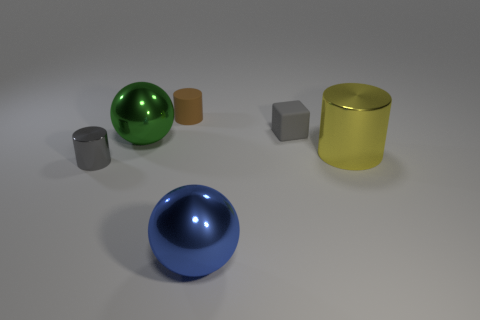There is a metal object in front of the tiny cylinder in front of the big yellow shiny cylinder; what shape is it?
Your response must be concise. Sphere. There is a gray object in front of the small gray thing that is to the right of the tiny cylinder that is on the right side of the tiny gray shiny cylinder; what size is it?
Ensure brevity in your answer.  Small. Do the brown cylinder and the yellow shiny thing have the same size?
Offer a terse response. No. How many things are either green spheres or tiny yellow matte blocks?
Offer a terse response. 1. How big is the gray thing behind the metal object behind the yellow metal thing?
Keep it short and to the point. Small. The brown rubber thing has what size?
Give a very brief answer. Small. There is a tiny object that is in front of the brown matte cylinder and on the left side of the tiny cube; what shape is it?
Provide a succinct answer. Cylinder. There is another big thing that is the same shape as the large green thing; what color is it?
Offer a very short reply. Blue. How many objects are large objects to the left of the blue thing or small cylinders that are on the right side of the small gray metal object?
Your response must be concise. 2. What is the shape of the small brown rubber object?
Your answer should be compact. Cylinder. 